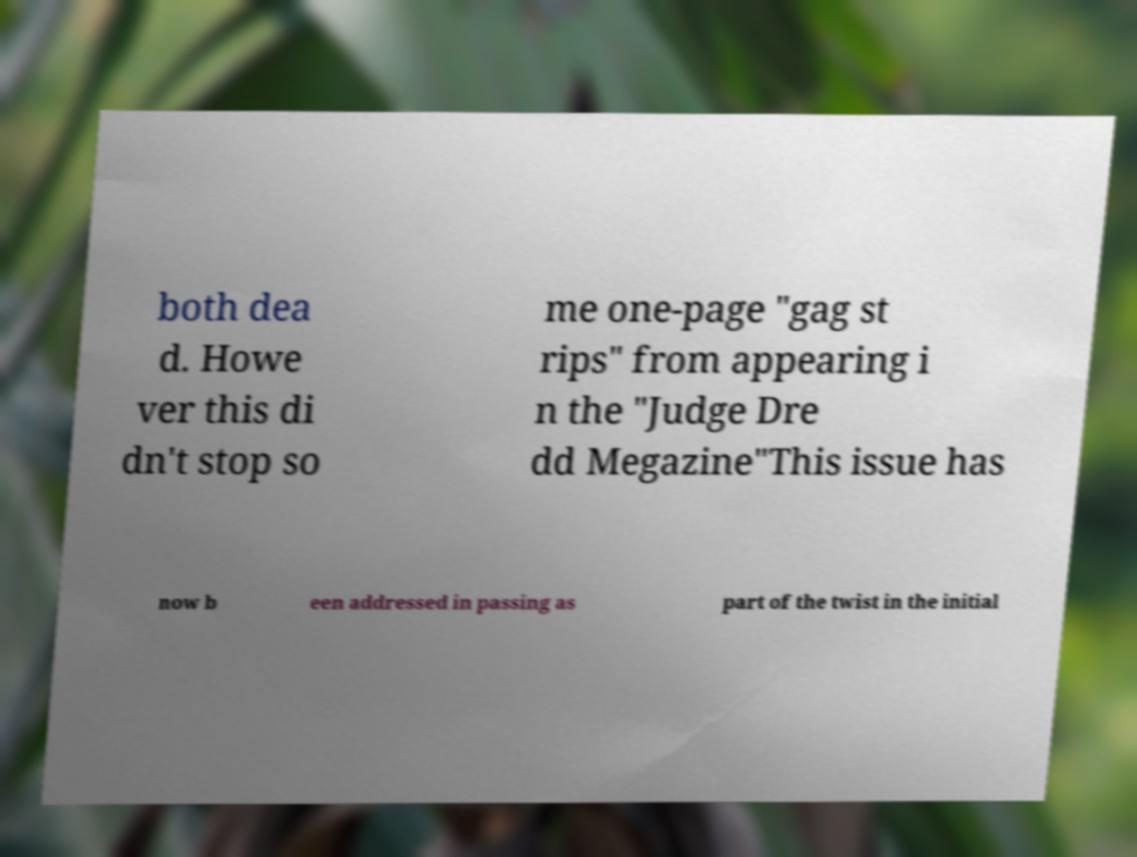Please identify and transcribe the text found in this image. both dea d. Howe ver this di dn't stop so me one-page "gag st rips" from appearing i n the "Judge Dre dd Megazine"This issue has now b een addressed in passing as part of the twist in the initial 